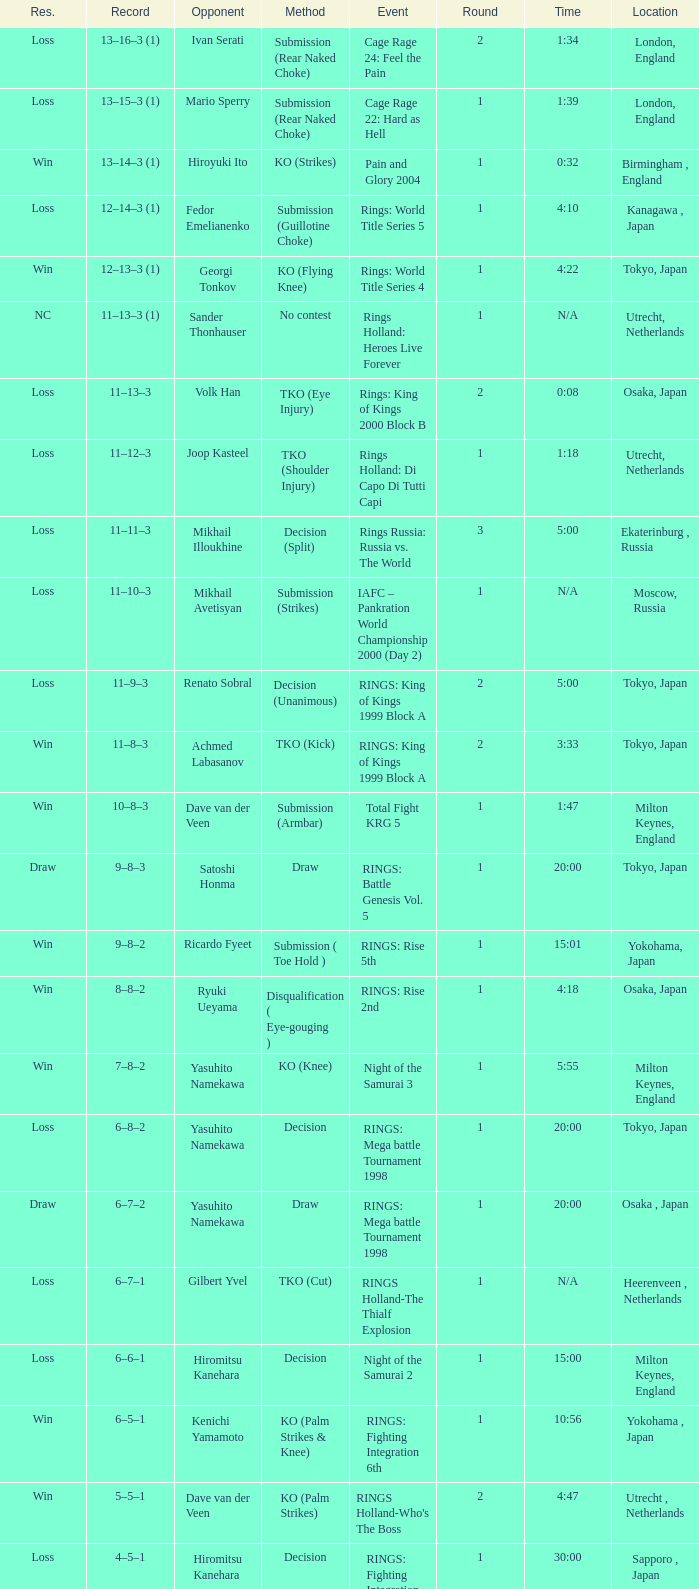Who was the opponent in London, England in a round less than 2? Mario Sperry. 